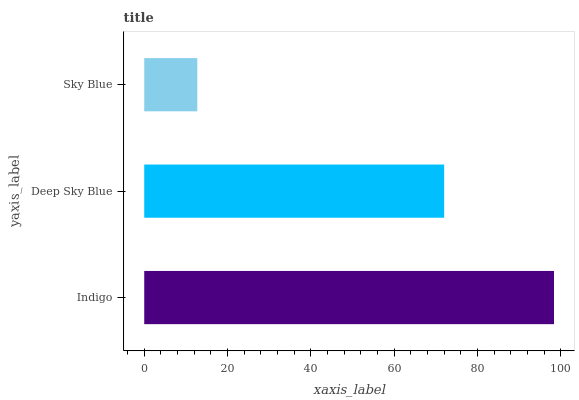Is Sky Blue the minimum?
Answer yes or no. Yes. Is Indigo the maximum?
Answer yes or no. Yes. Is Deep Sky Blue the minimum?
Answer yes or no. No. Is Deep Sky Blue the maximum?
Answer yes or no. No. Is Indigo greater than Deep Sky Blue?
Answer yes or no. Yes. Is Deep Sky Blue less than Indigo?
Answer yes or no. Yes. Is Deep Sky Blue greater than Indigo?
Answer yes or no. No. Is Indigo less than Deep Sky Blue?
Answer yes or no. No. Is Deep Sky Blue the high median?
Answer yes or no. Yes. Is Deep Sky Blue the low median?
Answer yes or no. Yes. Is Indigo the high median?
Answer yes or no. No. Is Indigo the low median?
Answer yes or no. No. 